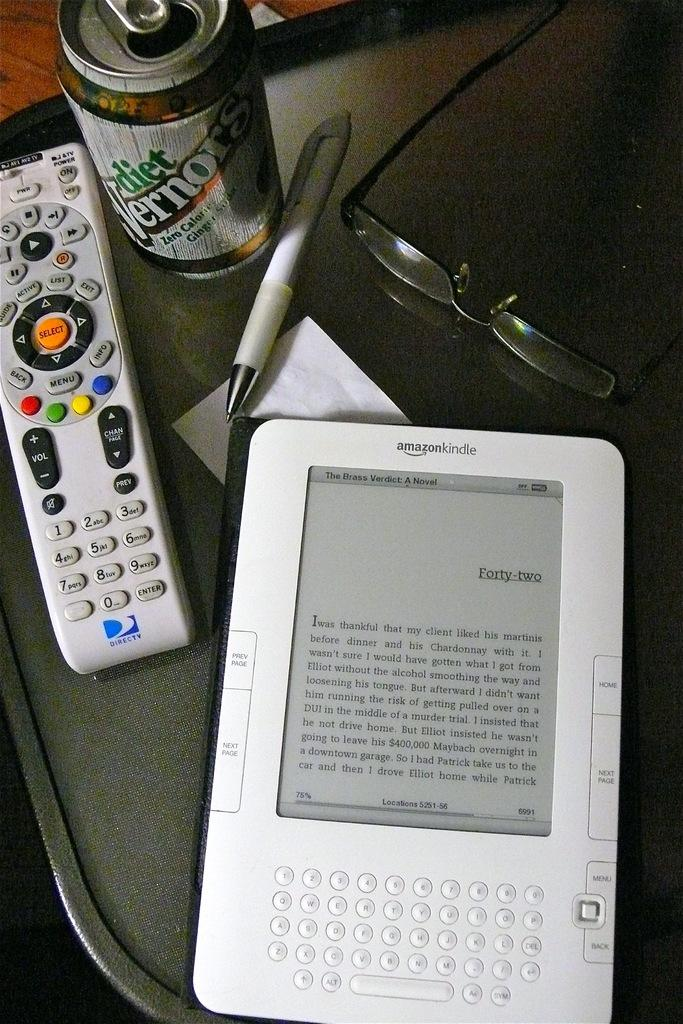<image>
Relay a brief, clear account of the picture shown. An Amazon Kindle is sitting on a table next to a Directv remote. 